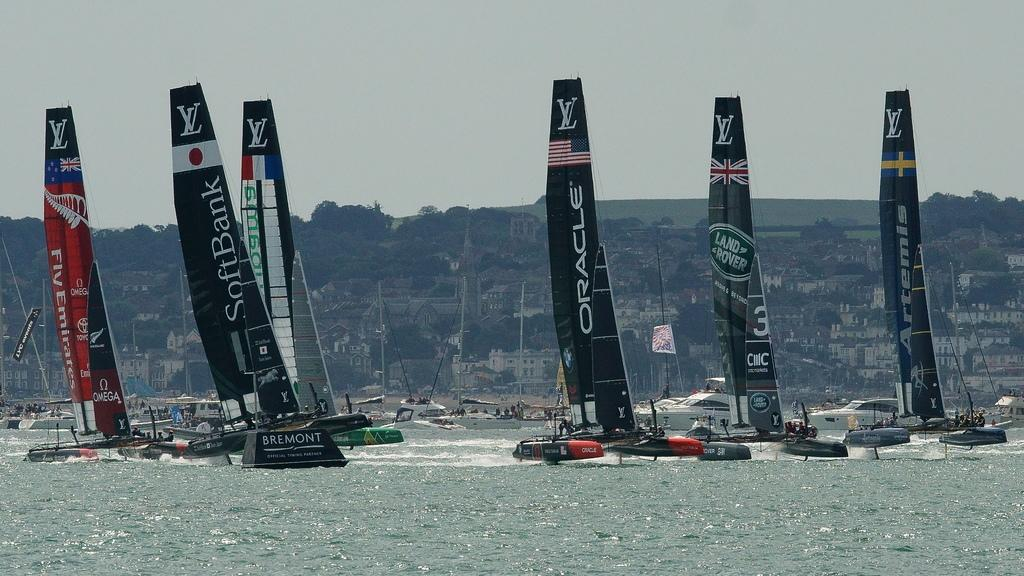What is the main element present in the image? There is water in the image. What is floating on the water? There are boats on the water. What structures can be seen in the image? There are buildings visible in the image. What is visible at the top of the image? The sky is visible at the top of the image. Can you tell me how many rooms are visible in the image? There are no rooms present in the image; it features water, boats, buildings, and the sky. What type of mist can be seen surrounding the boats in the image? There is no mist present in the image; the boats are floating on the water, and the sky is visible above. 